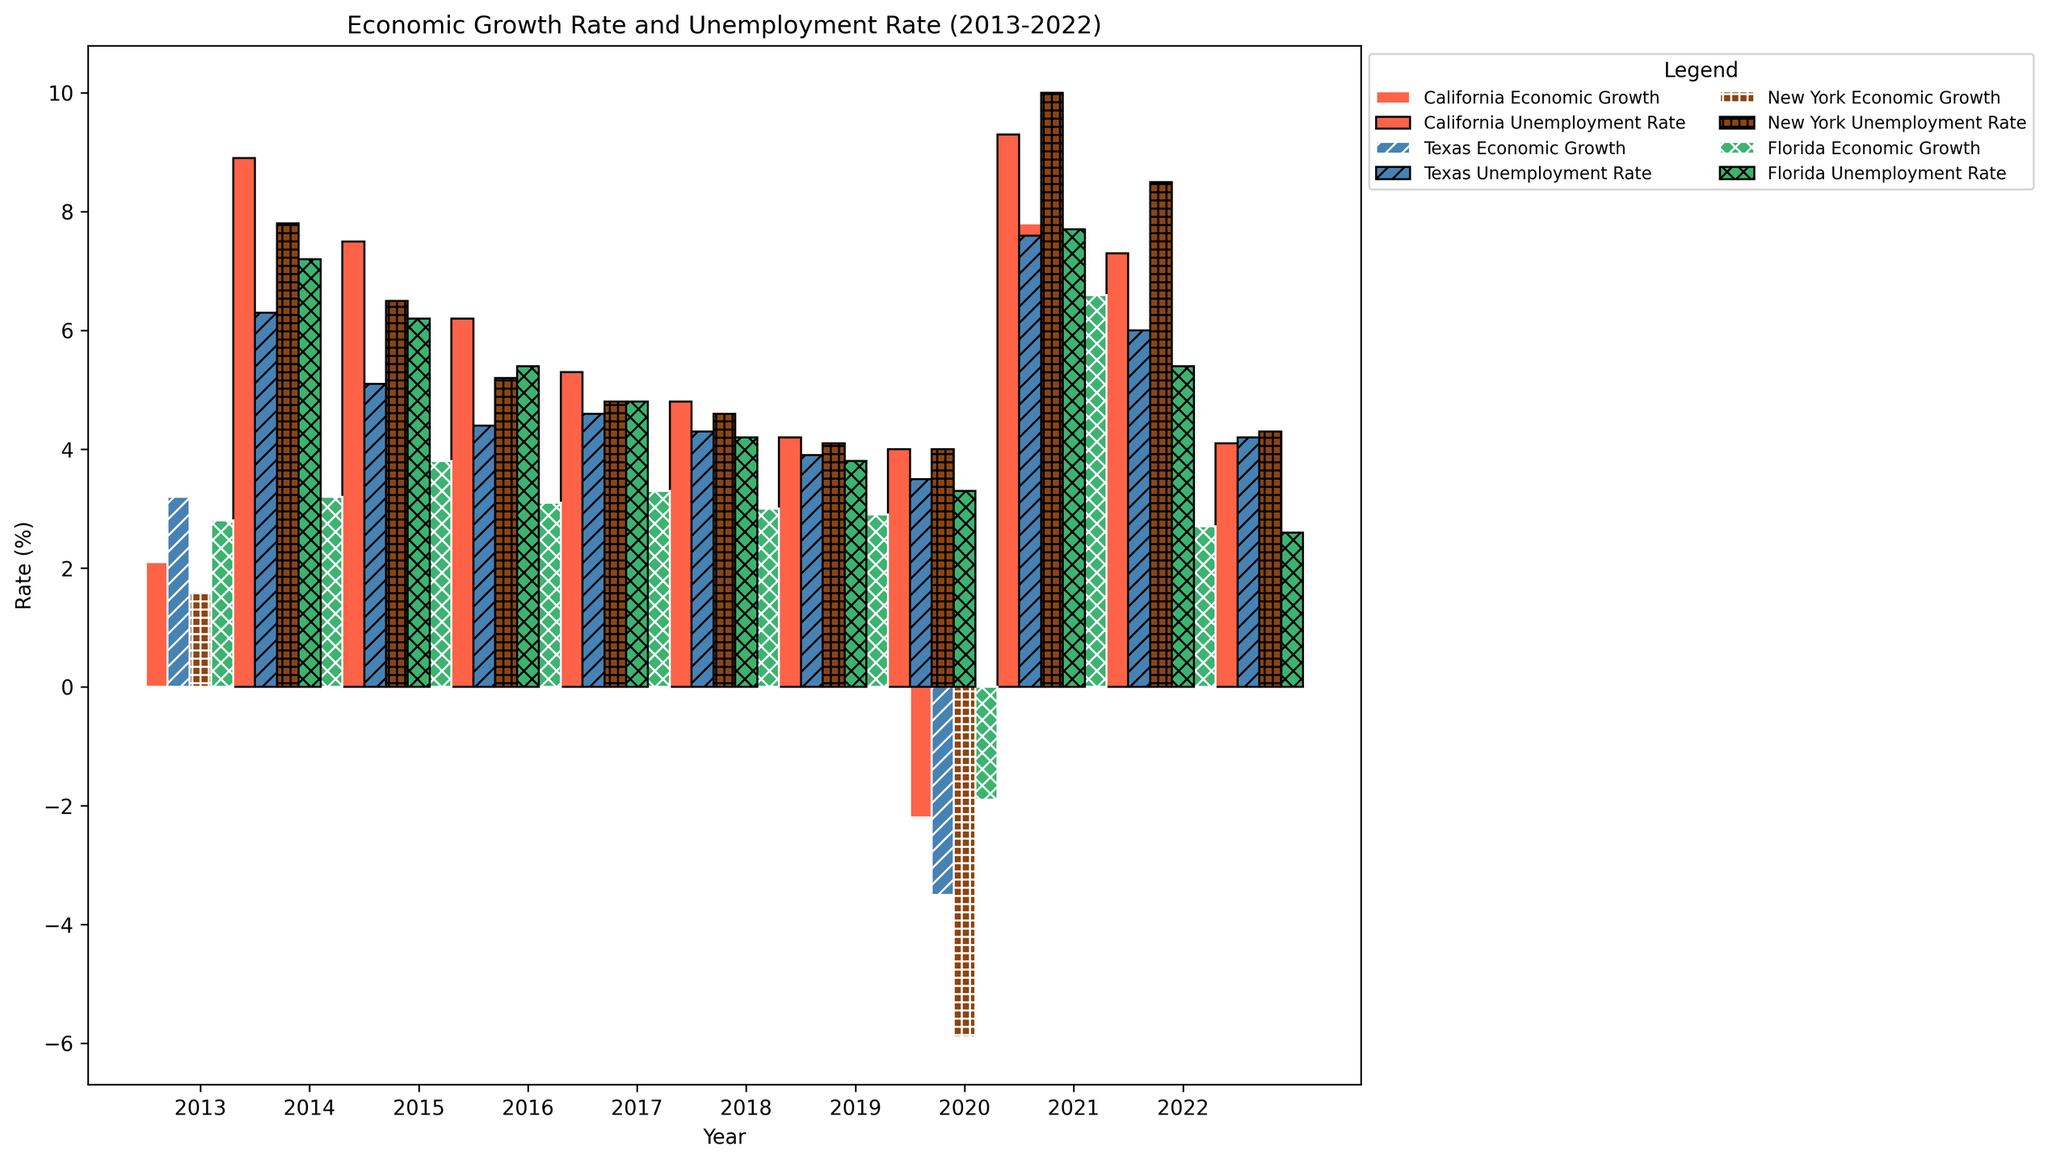Which state had the highest economic growth rate in 2021? Find the bar labeled with the highest economic growth rate for 2021. The tallest bar representing economic growth that year is for California.
Answer: California What is the difference in the unemployment rate between New York and Florida in 2020? Locate the bars for the unemployment rates of New York and Florida in 2020. New York's rate is 10.0%, and Florida's rate is 7.7%. Subtract Florida's rate from New York's rate: 10.0% - 7.7% = 2.3%.
Answer: 2.3% Which state experienced the most significant drop in economic growth rate in 2020 compared to 2019? Compare the economic growth rates for each state between 2019 and 2020. The largest drop is for New York, which went from 1.7% in 2019 to -5.9% in 2020, a drop of 7.6%.
Answer: New York In which year did Texas have its lowest unemployment rate, and what was this rate? Identify the bar representing Texas's unemployment rates and find the shortest one. The lowest rate for Texas is in 2019 at 3.5%.
Answer: 2019, 3.5% How does California's economic growth rate in 2022 compare to Texas's economic growth rate in the same year? Compare the heights of the economic growth rate bars for California and Texas in 2022. California's bar is slightly lower than Texas's bar in 2022.
Answer: Lower What was the average economic growth rate for Florida between 2013 and 2022? Add up Florida's economic growth rates for all ten years, then divide by the number of years: (2.8 + 3.2 + 3.8 + 3.1 + 3.3 + 3.0 + 2.9 - 1.9 + 6.6 + 2.7) / 10 = 2.65%.
Answer: 2.65% Which state had the smaller unemployment rate in 2017: New York or Texas? Compare the heights of the unemployment rate bars for New York and Texas in 2017. Texas's bar is slightly lower than New York's.
Answer: Texas By how much did the economic growth rate change in California between 2018 and 2021? Find the economic growth rates for California in 2018 and 2021. The rate was 3.5% in 2018 and 7.8% in 2021. The difference is 7.8% - 3.5% = 4.3%.
Answer: 4.3% Which state had the highest unemployment rate in 2020, and what was the rate? Look for the tallest unemployment rate bar in 2020 across all states. New York's bar is the tallest with a rate of 10.0%.
Answer: New York, 10.0% Did any state have negative economic growth in 2020, and how many? Identify bars representing economic growth for 2020, and check if any are below 0%. Four states (California, Texas, New York, Florida) had negative growth in 2020.
Answer: Yes, 4 